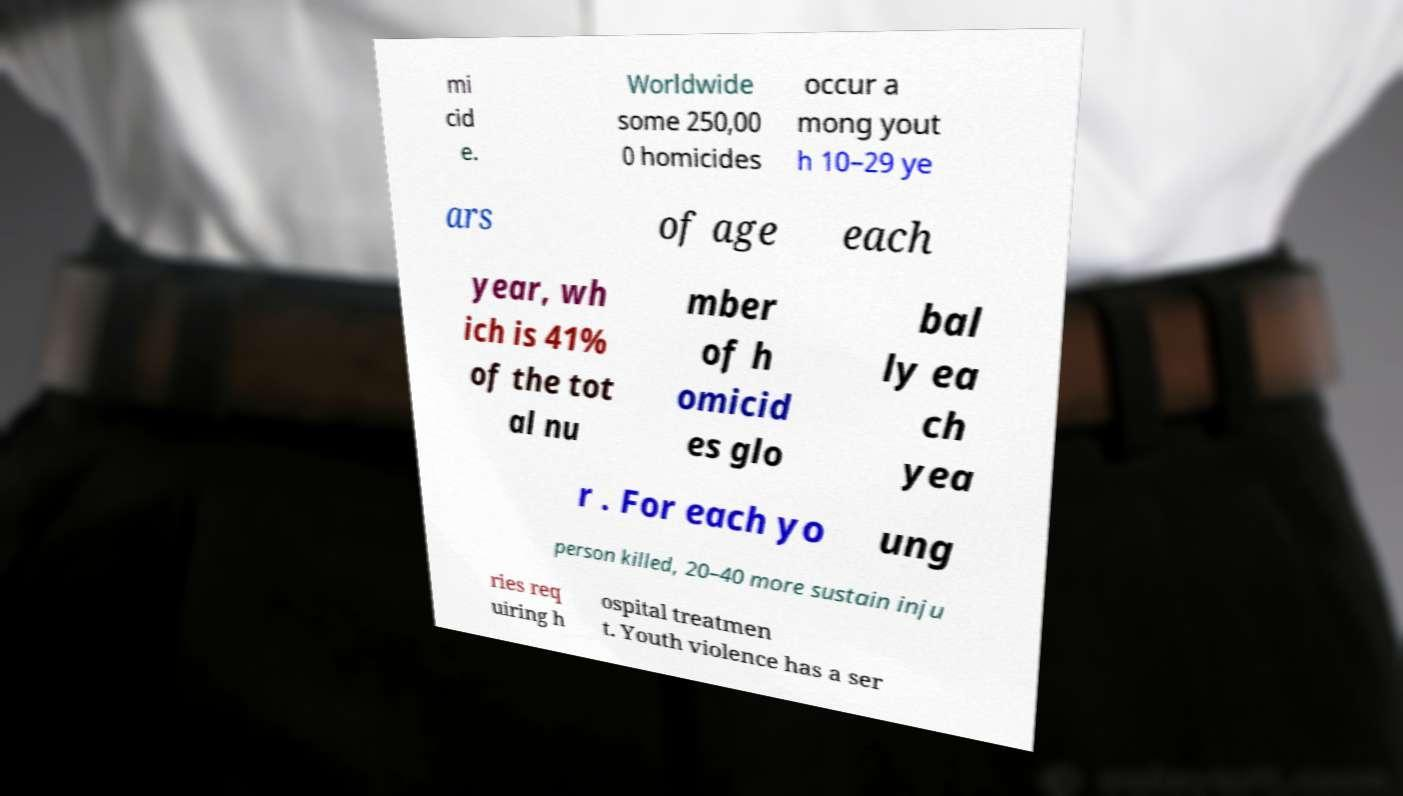Please read and relay the text visible in this image. What does it say? mi cid e. Worldwide some 250,00 0 homicides occur a mong yout h 10–29 ye ars of age each year, wh ich is 41% of the tot al nu mber of h omicid es glo bal ly ea ch yea r . For each yo ung person killed, 20–40 more sustain inju ries req uiring h ospital treatmen t. Youth violence has a ser 